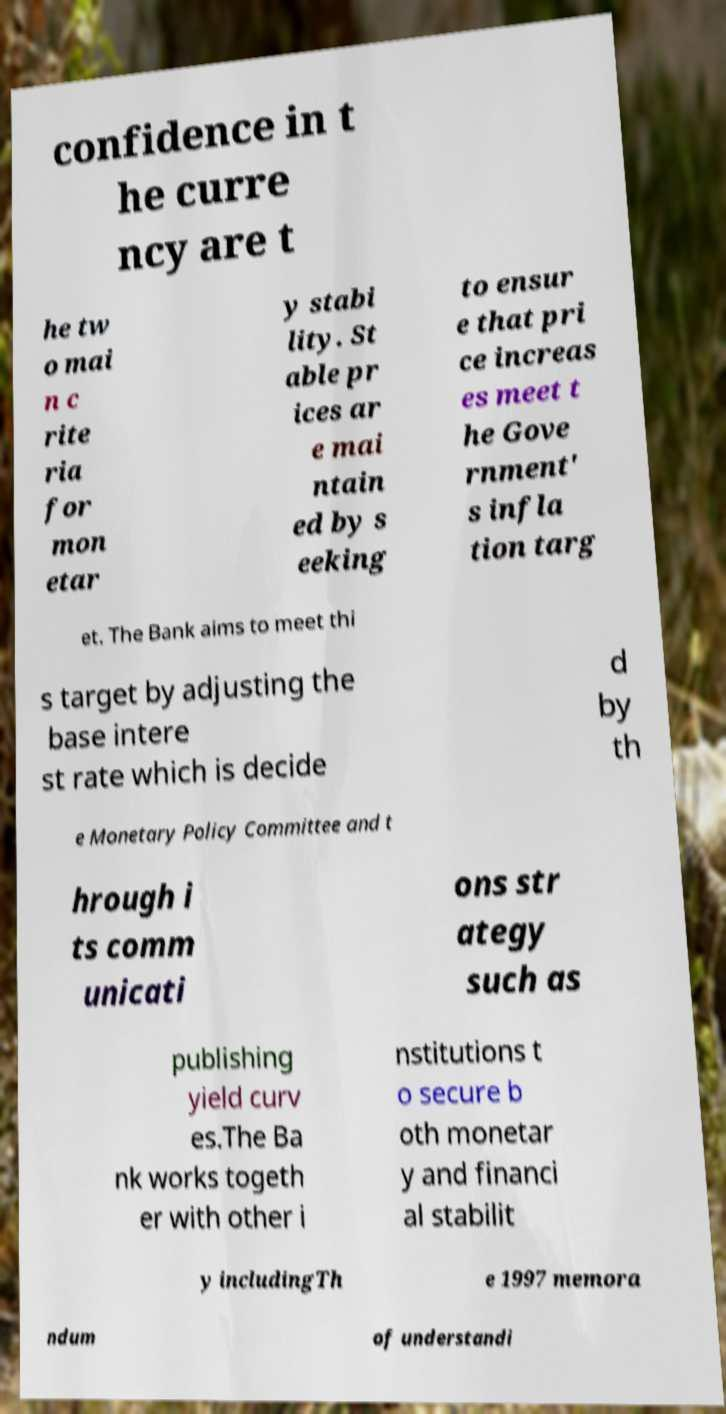Please read and relay the text visible in this image. What does it say? confidence in t he curre ncy are t he tw o mai n c rite ria for mon etar y stabi lity. St able pr ices ar e mai ntain ed by s eeking to ensur e that pri ce increas es meet t he Gove rnment' s infla tion targ et. The Bank aims to meet thi s target by adjusting the base intere st rate which is decide d by th e Monetary Policy Committee and t hrough i ts comm unicati ons str ategy such as publishing yield curv es.The Ba nk works togeth er with other i nstitutions t o secure b oth monetar y and financi al stabilit y includingTh e 1997 memora ndum of understandi 